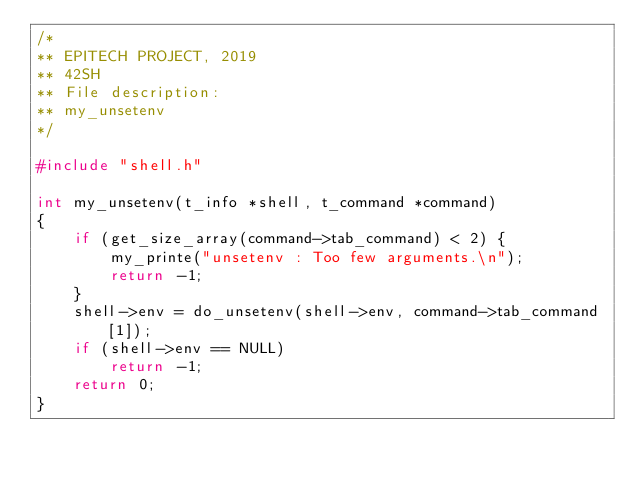Convert code to text. <code><loc_0><loc_0><loc_500><loc_500><_C_>/*
** EPITECH PROJECT, 2019
** 42SH
** File description:
** my_unsetenv
*/

#include "shell.h"

int my_unsetenv(t_info *shell, t_command *command)
{
    if (get_size_array(command->tab_command) < 2) {
        my_printe("unsetenv : Too few arguments.\n");
        return -1;
    }
    shell->env = do_unsetenv(shell->env, command->tab_command[1]);
    if (shell->env == NULL)
        return -1;
    return 0;
}
</code> 